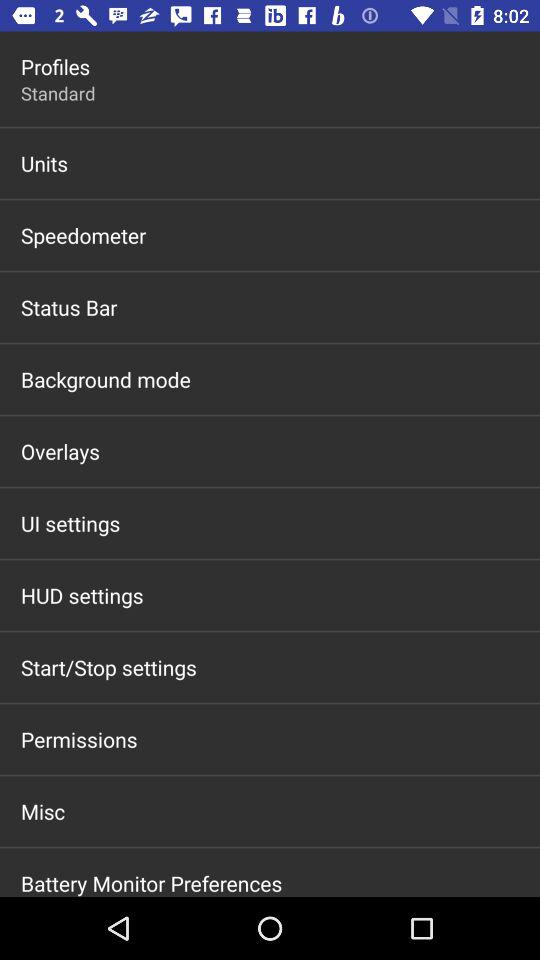What's the setting for "Profiles"? The setting is "Standard". 